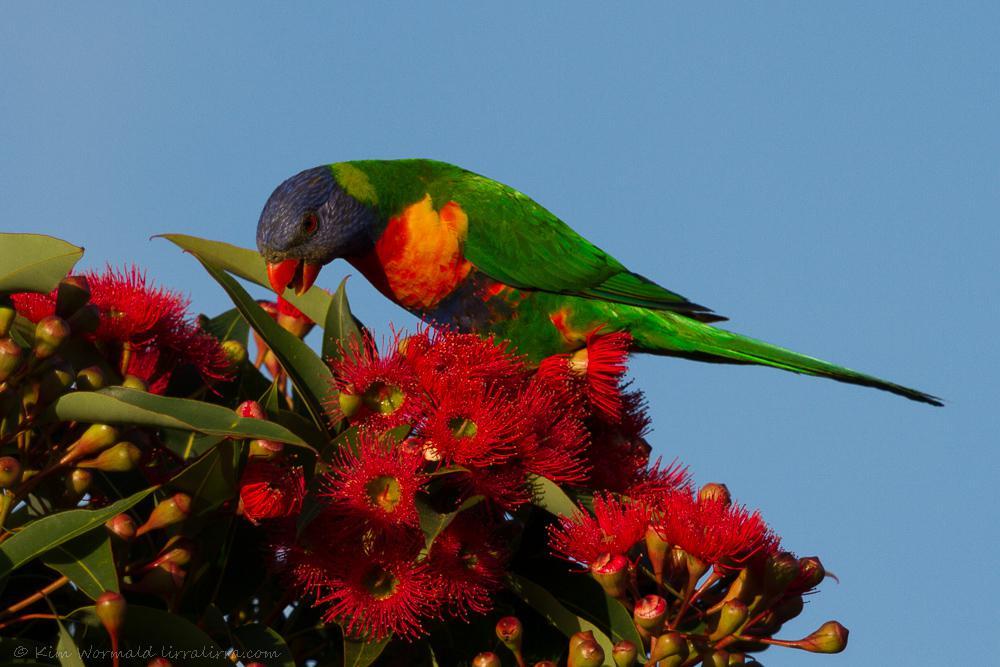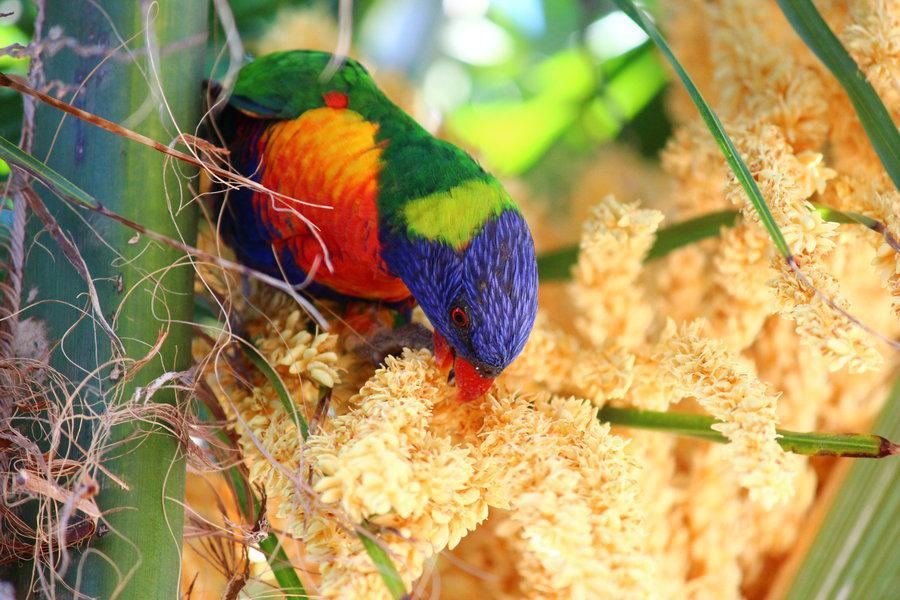The first image is the image on the left, the second image is the image on the right. Considering the images on both sides, is "An image shows exactly one parrot perched among branches of red flowers with tendril petals." valid? Answer yes or no. Yes. 